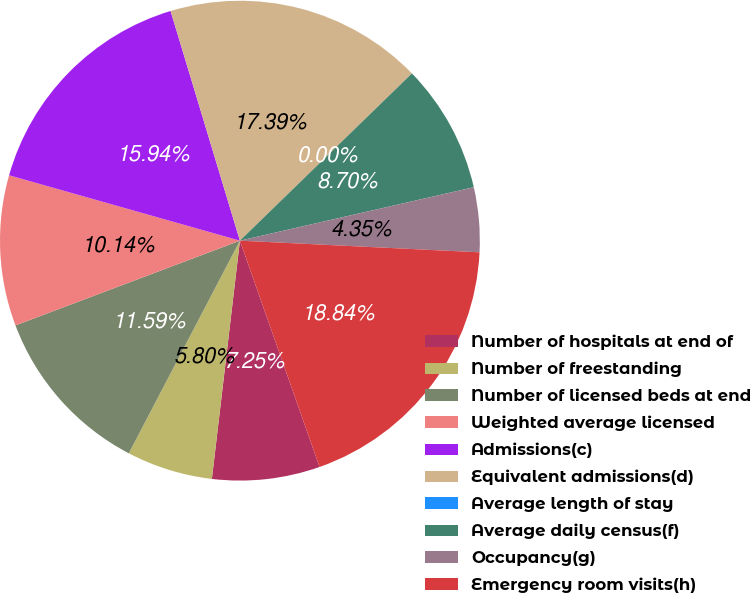Convert chart to OTSL. <chart><loc_0><loc_0><loc_500><loc_500><pie_chart><fcel>Number of hospitals at end of<fcel>Number of freestanding<fcel>Number of licensed beds at end<fcel>Weighted average licensed<fcel>Admissions(c)<fcel>Equivalent admissions(d)<fcel>Average length of stay<fcel>Average daily census(f)<fcel>Occupancy(g)<fcel>Emergency room visits(h)<nl><fcel>7.25%<fcel>5.8%<fcel>11.59%<fcel>10.14%<fcel>15.94%<fcel>17.39%<fcel>0.0%<fcel>8.7%<fcel>4.35%<fcel>18.84%<nl></chart> 